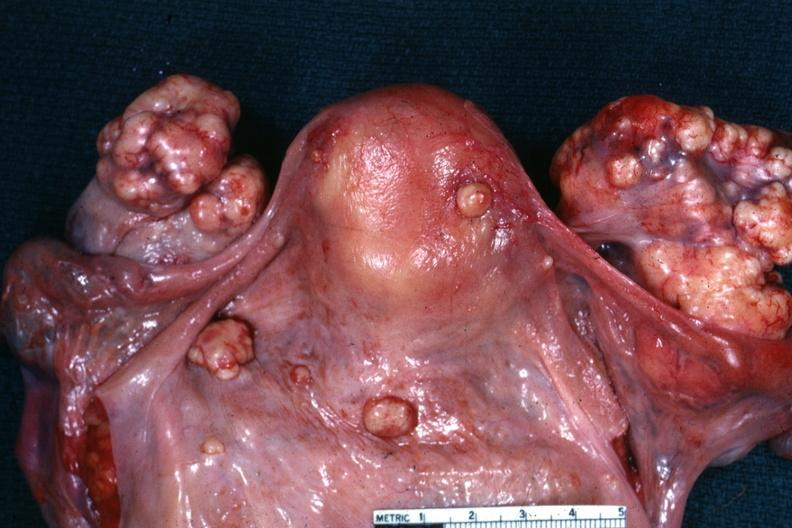s female reproductive present?
Answer the question using a single word or phrase. Yes 